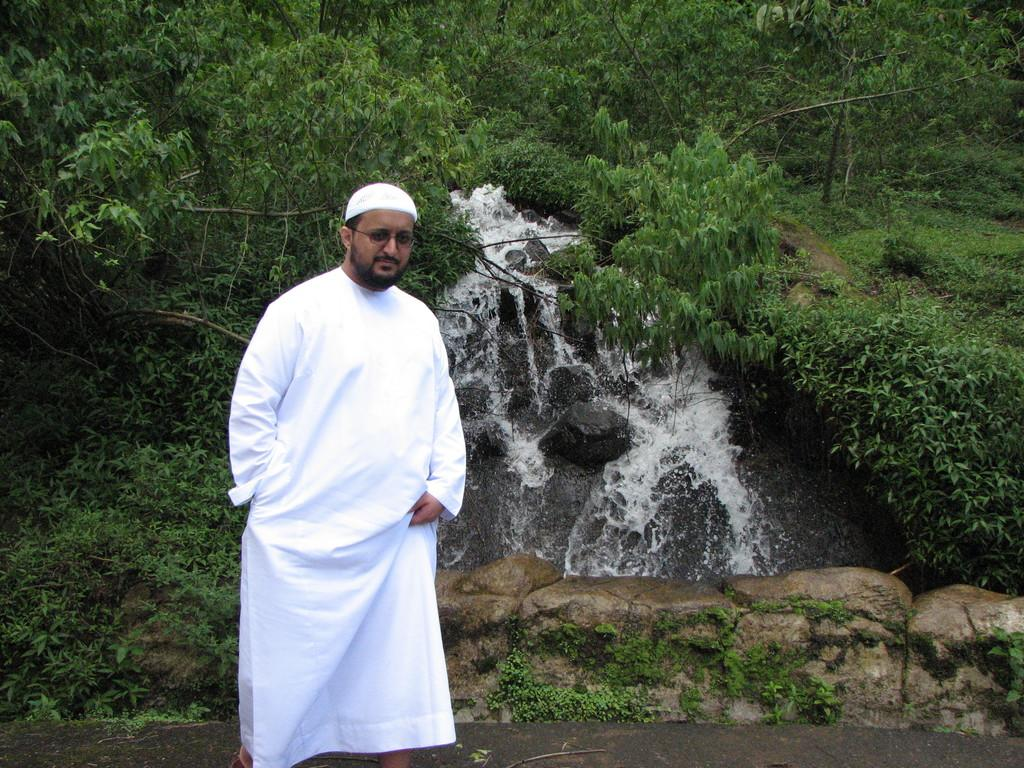What is the main subject of the image? There is a person standing in the center of the image. What can be seen in the background of the image? Water, trees, plants, grass, and stones are present in the background. What rule does the coach enforce in the image? There is no coach or rule present in the image; it features a person standing in the center and natural elements in the background. 